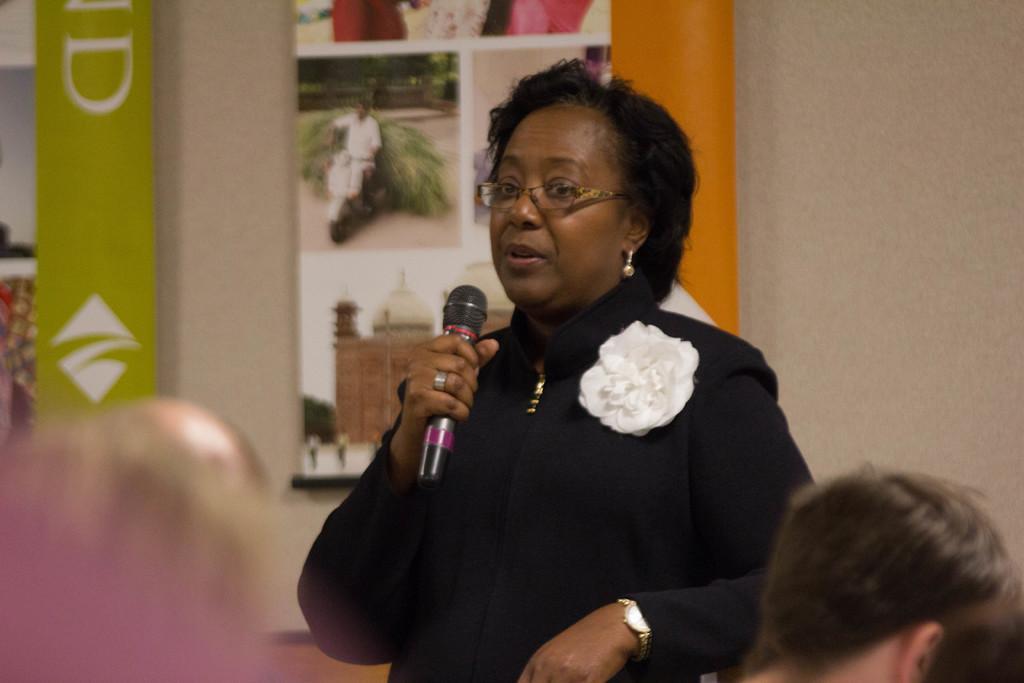In one or two sentences, can you explain what this image depicts? In this image a woman wearing a black top, spectacles, watch is holding a mike. At the right bottom corner there are few persons. Backside of her there are few photos attached to the wall. 